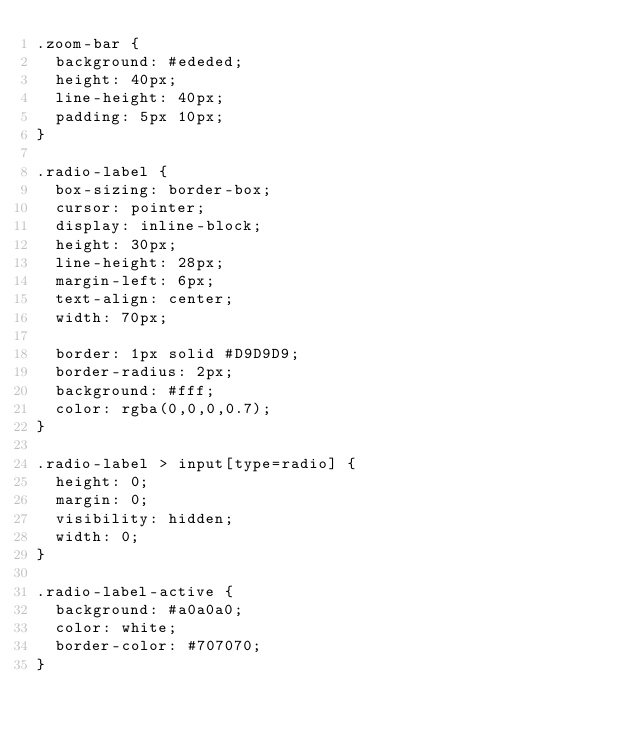<code> <loc_0><loc_0><loc_500><loc_500><_CSS_>.zoom-bar {
  background: #ededed;
  height: 40px;
  line-height: 40px;
  padding: 5px 10px;
}

.radio-label {
  box-sizing: border-box;
  cursor: pointer;
  display: inline-block;
  height: 30px;
  line-height: 28px;
  margin-left: 6px;
  text-align: center;
  width: 70px;

  border: 1px solid #D9D9D9;
  border-radius: 2px;
  background: #fff;
  color: rgba(0,0,0,0.7);
}

.radio-label > input[type=radio] {
  height: 0;
  margin: 0;
  visibility: hidden;
  width: 0;
}

.radio-label-active {
  background: #a0a0a0;
  color: white;
  border-color: #707070;
}</code> 